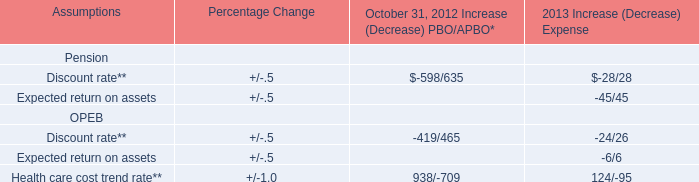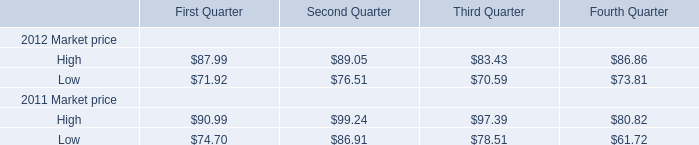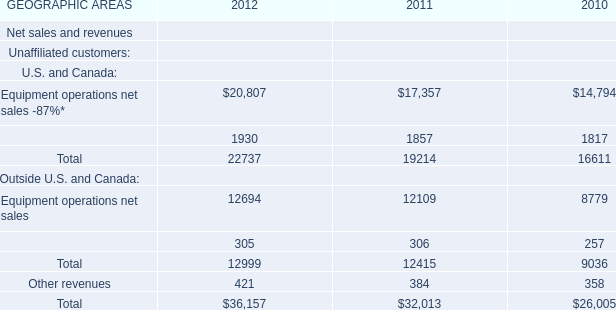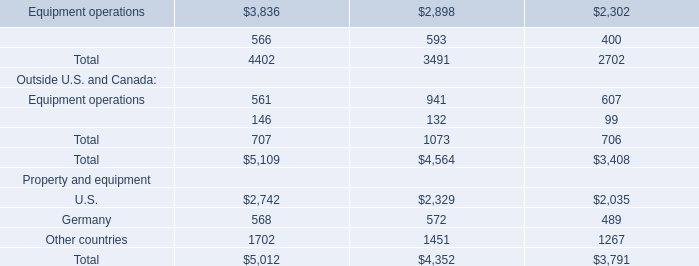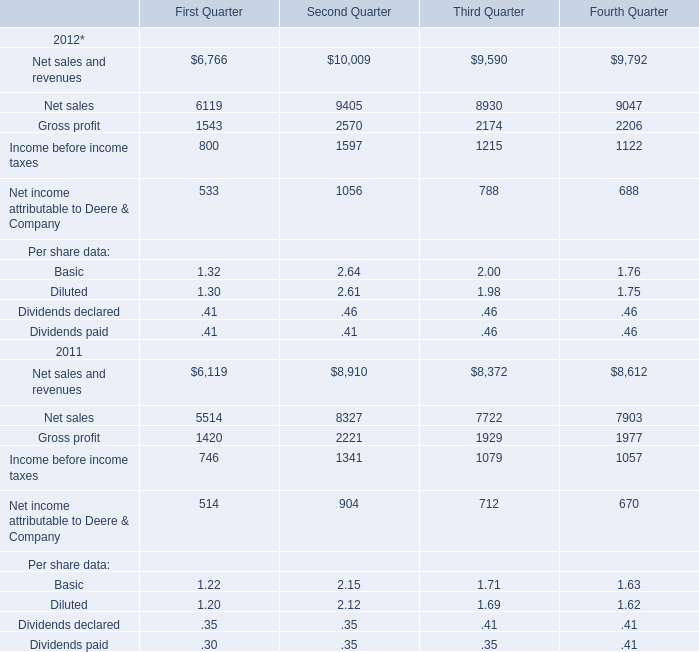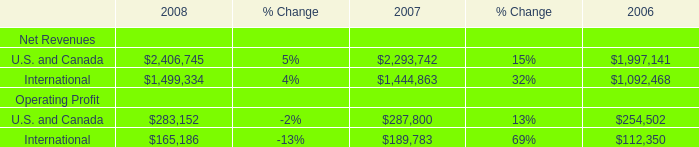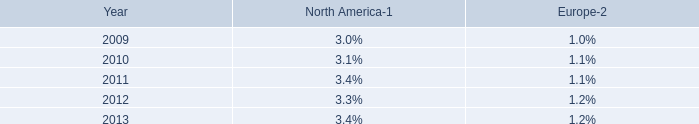what is the average berths capacity on mein schiff 1 and mein schiff 2? 
Computations: (3800 / 2)
Answer: 1900.0. 